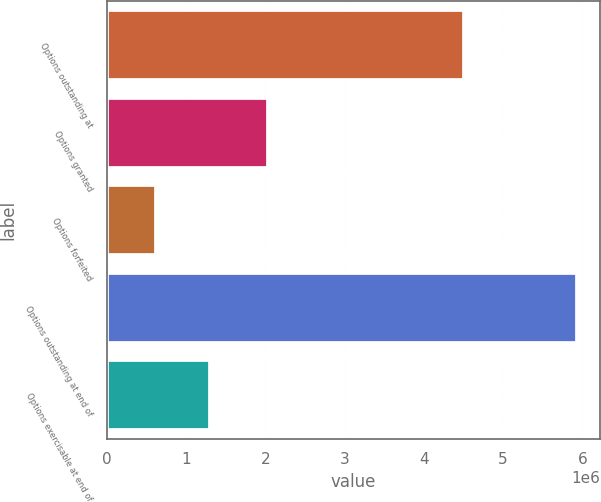Convert chart to OTSL. <chart><loc_0><loc_0><loc_500><loc_500><bar_chart><fcel>Options outstanding at<fcel>Options granted<fcel>Options forfeited<fcel>Options outstanding at end of<fcel>Options exercisable at end of<nl><fcel>4.50906e+06<fcel>2.037e+06<fcel>614000<fcel>5.93206e+06<fcel>1.29661e+06<nl></chart> 